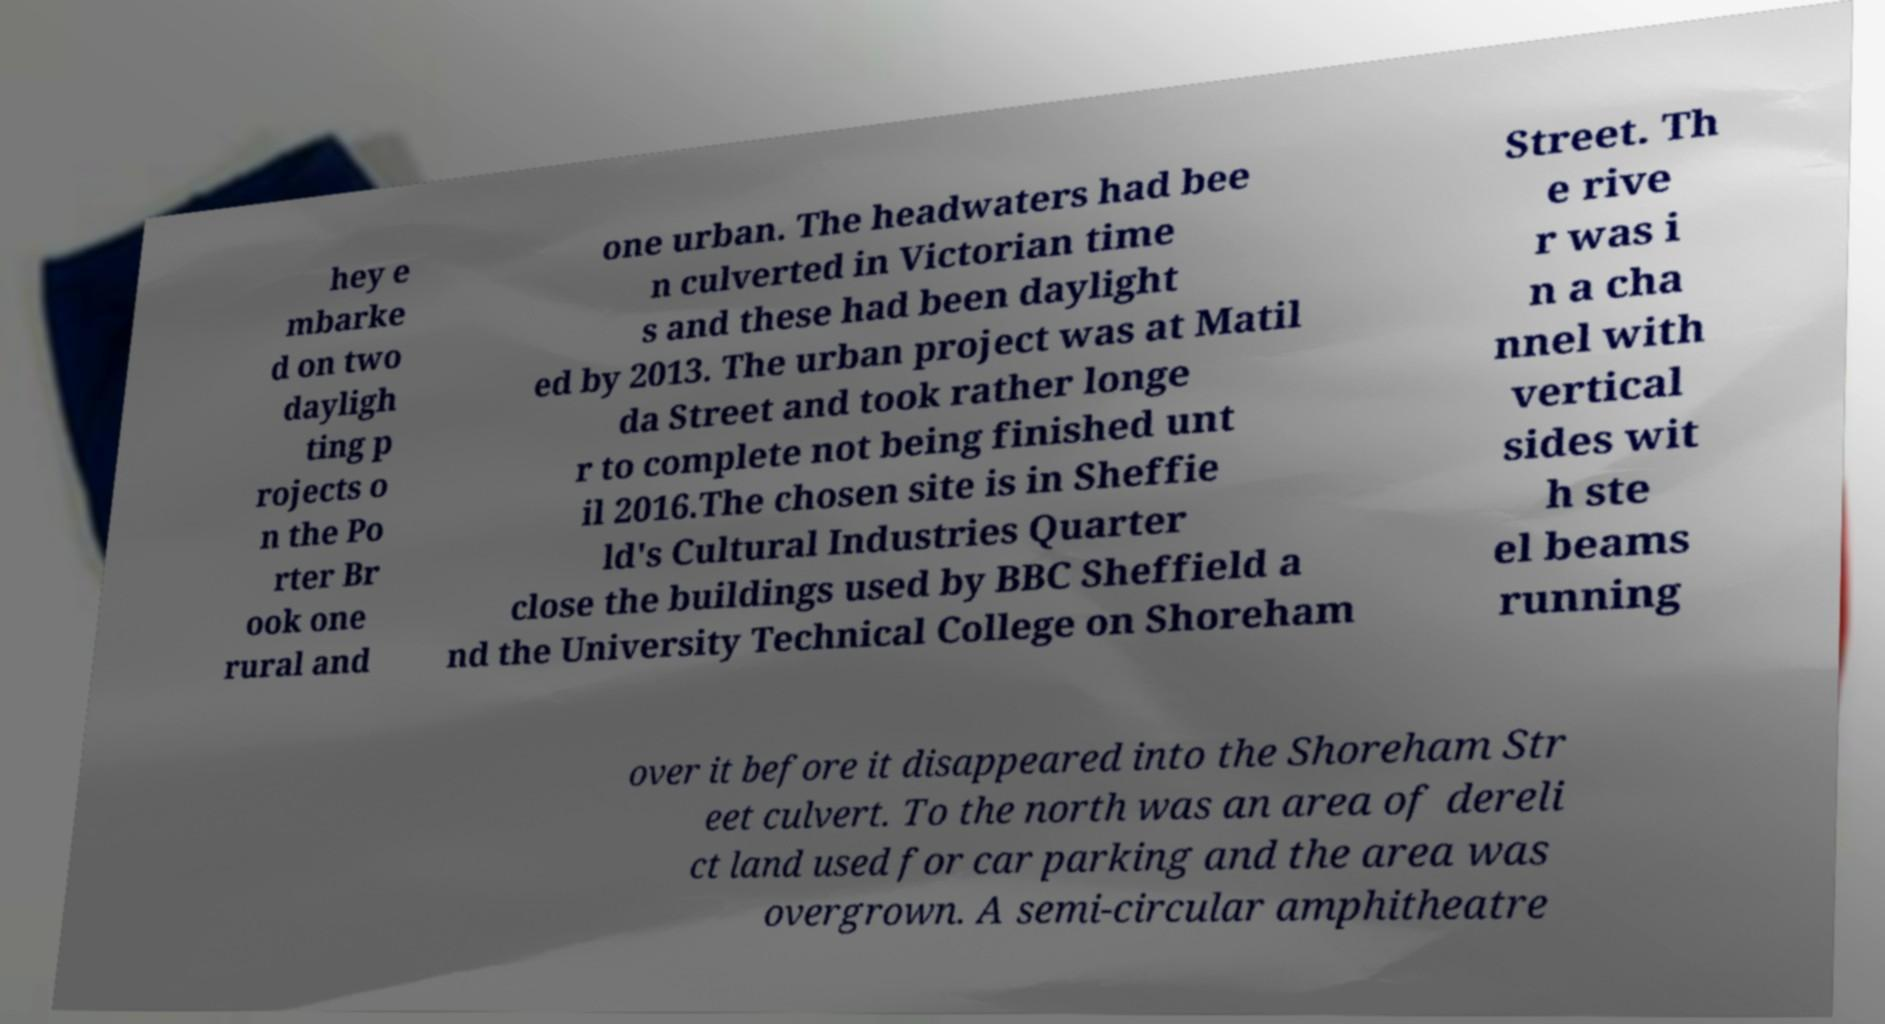I need the written content from this picture converted into text. Can you do that? hey e mbarke d on two dayligh ting p rojects o n the Po rter Br ook one rural and one urban. The headwaters had bee n culverted in Victorian time s and these had been daylight ed by 2013. The urban project was at Matil da Street and took rather longe r to complete not being finished unt il 2016.The chosen site is in Sheffie ld's Cultural Industries Quarter close the buildings used by BBC Sheffield a nd the University Technical College on Shoreham Street. Th e rive r was i n a cha nnel with vertical sides wit h ste el beams running over it before it disappeared into the Shoreham Str eet culvert. To the north was an area of dereli ct land used for car parking and the area was overgrown. A semi-circular amphitheatre 